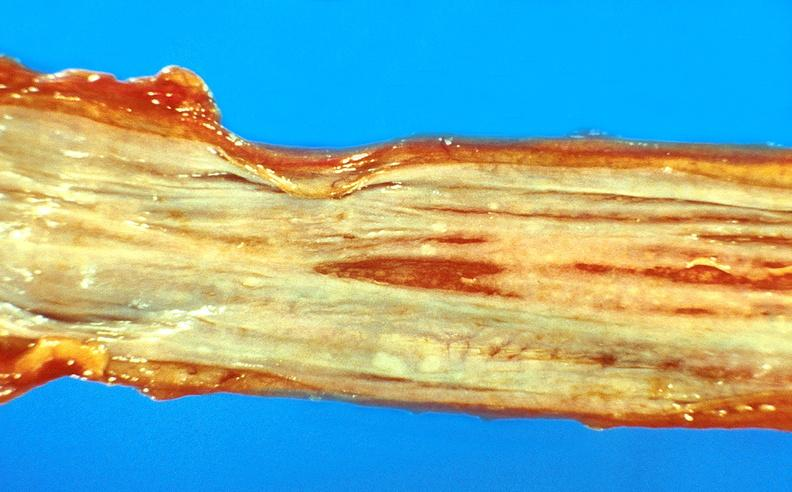what does this image show?
Answer the question using a single word or phrase. Esophageal varices 